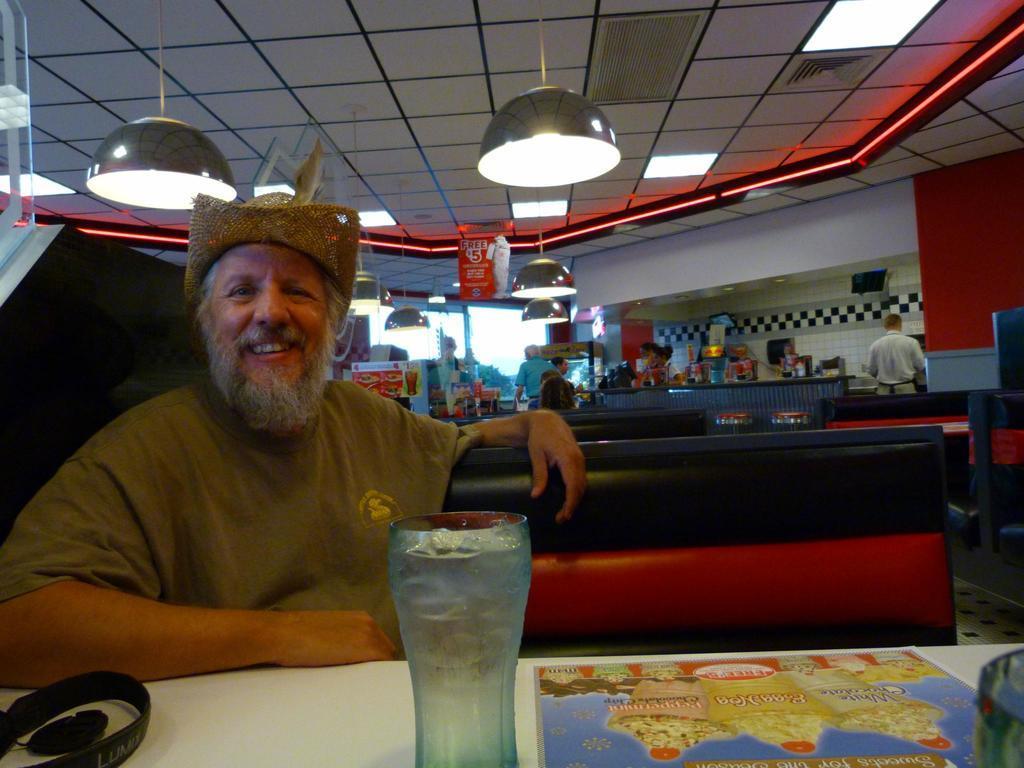Can you describe this image briefly? In this image I can see a person wearing t shirt is sitting on a couch which is black and red in color in front of a white colored table and on the table I can see a black colored object, a glass and a board. In the background I can see the ceiling, few lights, few other persons standing and few other objects. 